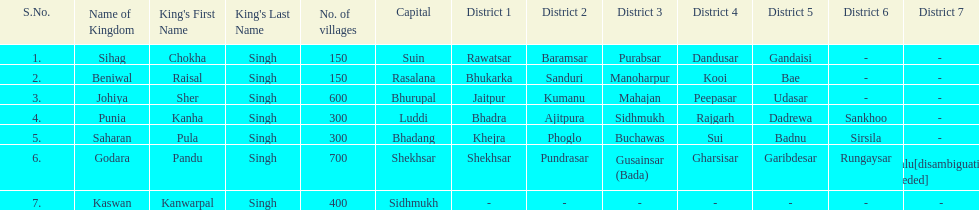He was the king of the sihag kingdom. Chokha Singh. 